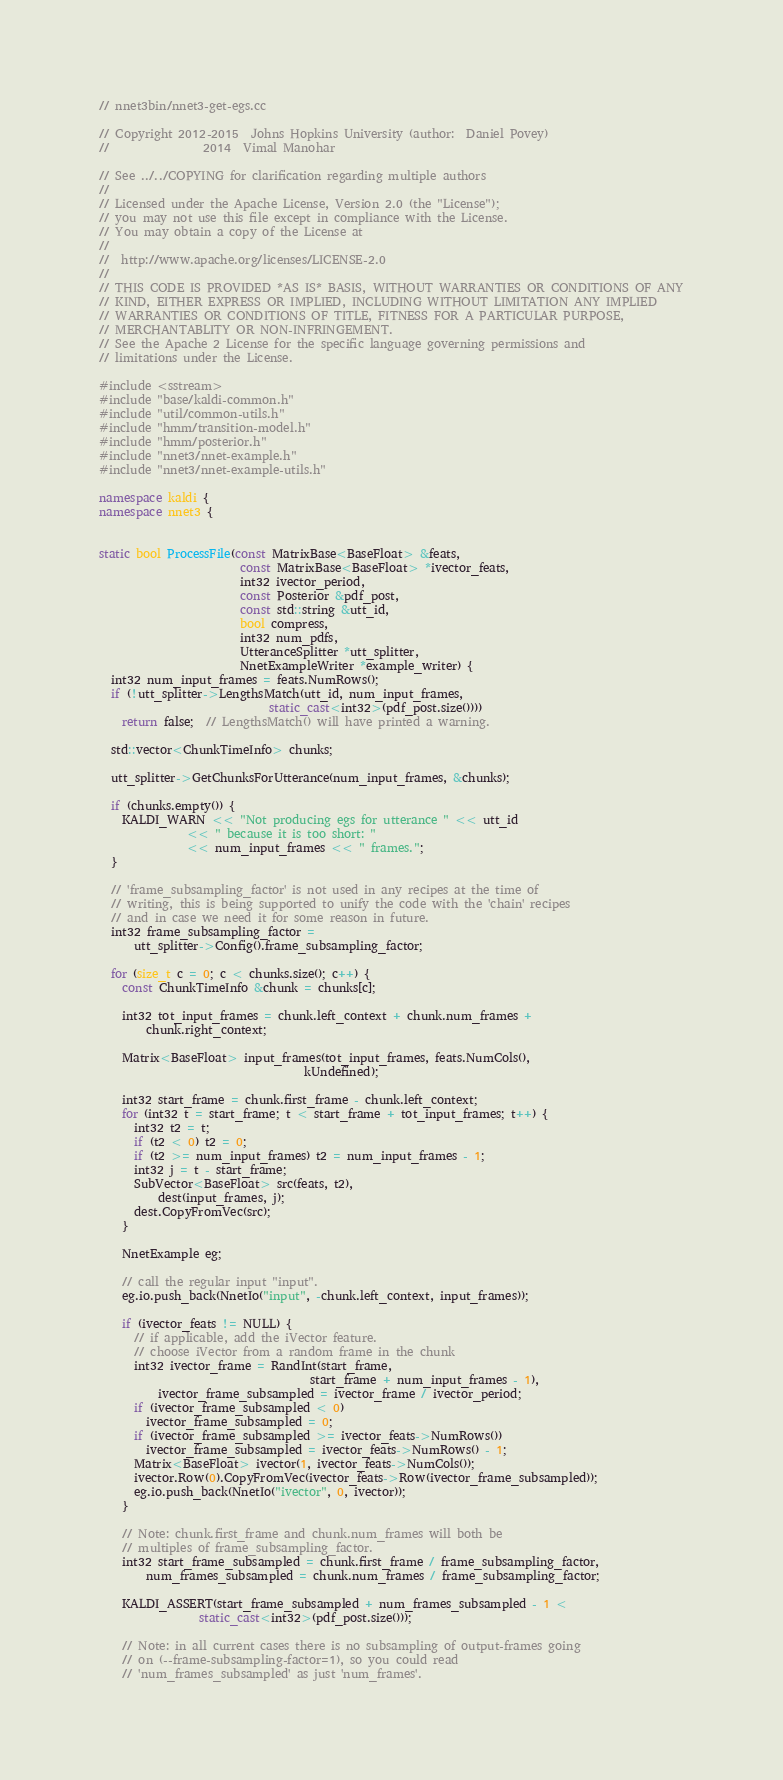<code> <loc_0><loc_0><loc_500><loc_500><_C++_>// nnet3bin/nnet3-get-egs.cc

// Copyright 2012-2015  Johns Hopkins University (author:  Daniel Povey)
//                2014  Vimal Manohar

// See ../../COPYING for clarification regarding multiple authors
//
// Licensed under the Apache License, Version 2.0 (the "License");
// you may not use this file except in compliance with the License.
// You may obtain a copy of the License at
//
//  http://www.apache.org/licenses/LICENSE-2.0
//
// THIS CODE IS PROVIDED *AS IS* BASIS, WITHOUT WARRANTIES OR CONDITIONS OF ANY
// KIND, EITHER EXPRESS OR IMPLIED, INCLUDING WITHOUT LIMITATION ANY IMPLIED
// WARRANTIES OR CONDITIONS OF TITLE, FITNESS FOR A PARTICULAR PURPOSE,
// MERCHANTABLITY OR NON-INFRINGEMENT.
// See the Apache 2 License for the specific language governing permissions and
// limitations under the License.

#include <sstream>
#include "base/kaldi-common.h"
#include "util/common-utils.h"
#include "hmm/transition-model.h"
#include "hmm/posterior.h"
#include "nnet3/nnet-example.h"
#include "nnet3/nnet-example-utils.h"

namespace kaldi {
namespace nnet3 {


static bool ProcessFile(const MatrixBase<BaseFloat> &feats,
                        const MatrixBase<BaseFloat> *ivector_feats,
                        int32 ivector_period,
                        const Posterior &pdf_post,
                        const std::string &utt_id,
                        bool compress,
                        int32 num_pdfs,
                        UtteranceSplitter *utt_splitter,
                        NnetExampleWriter *example_writer) {
  int32 num_input_frames = feats.NumRows();
  if (!utt_splitter->LengthsMatch(utt_id, num_input_frames,
                             static_cast<int32>(pdf_post.size())))
    return false;  // LengthsMatch() will have printed a warning.

  std::vector<ChunkTimeInfo> chunks;

  utt_splitter->GetChunksForUtterance(num_input_frames, &chunks);

  if (chunks.empty()) {
    KALDI_WARN << "Not producing egs for utterance " << utt_id
               << " because it is too short: "
               << num_input_frames << " frames.";
  }

  // 'frame_subsampling_factor' is not used in any recipes at the time of
  // writing, this is being supported to unify the code with the 'chain' recipes
  // and in case we need it for some reason in future.
  int32 frame_subsampling_factor =
      utt_splitter->Config().frame_subsampling_factor;

  for (size_t c = 0; c < chunks.size(); c++) {
    const ChunkTimeInfo &chunk = chunks[c];

    int32 tot_input_frames = chunk.left_context + chunk.num_frames +
        chunk.right_context;

    Matrix<BaseFloat> input_frames(tot_input_frames, feats.NumCols(),
                                   kUndefined);

    int32 start_frame = chunk.first_frame - chunk.left_context;
    for (int32 t = start_frame; t < start_frame + tot_input_frames; t++) {
      int32 t2 = t;
      if (t2 < 0) t2 = 0;
      if (t2 >= num_input_frames) t2 = num_input_frames - 1;
      int32 j = t - start_frame;
      SubVector<BaseFloat> src(feats, t2),
          dest(input_frames, j);
      dest.CopyFromVec(src);
    }

    NnetExample eg;

    // call the regular input "input".
    eg.io.push_back(NnetIo("input", -chunk.left_context, input_frames));

    if (ivector_feats != NULL) {
      // if applicable, add the iVector feature.
      // choose iVector from a random frame in the chunk
      int32 ivector_frame = RandInt(start_frame,
                                    start_frame + num_input_frames - 1),
          ivector_frame_subsampled = ivector_frame / ivector_period;
      if (ivector_frame_subsampled < 0)
        ivector_frame_subsampled = 0;
      if (ivector_frame_subsampled >= ivector_feats->NumRows())
        ivector_frame_subsampled = ivector_feats->NumRows() - 1;
      Matrix<BaseFloat> ivector(1, ivector_feats->NumCols());
      ivector.Row(0).CopyFromVec(ivector_feats->Row(ivector_frame_subsampled));
      eg.io.push_back(NnetIo("ivector", 0, ivector));
    }

    // Note: chunk.first_frame and chunk.num_frames will both be
    // multiples of frame_subsampling_factor.
    int32 start_frame_subsampled = chunk.first_frame / frame_subsampling_factor,
        num_frames_subsampled = chunk.num_frames / frame_subsampling_factor;

    KALDI_ASSERT(start_frame_subsampled + num_frames_subsampled - 1 <
                 static_cast<int32>(pdf_post.size()));

    // Note: in all current cases there is no subsampling of output-frames going
    // on (--frame-subsampling-factor=1), so you could read
    // 'num_frames_subsampled' as just 'num_frames'.</code> 